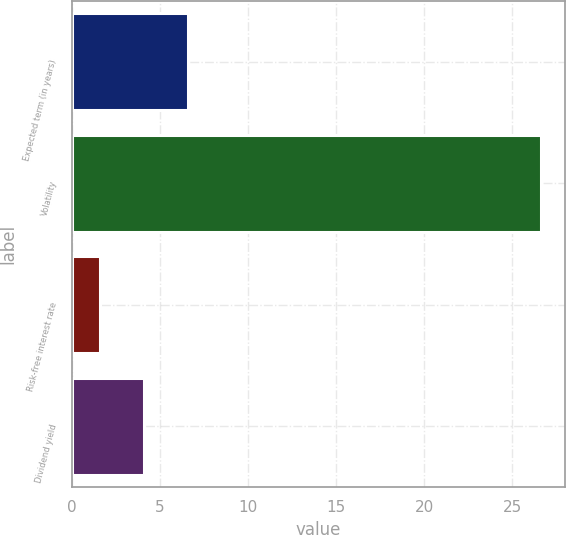Convert chart to OTSL. <chart><loc_0><loc_0><loc_500><loc_500><bar_chart><fcel>Expected term (in years)<fcel>Volatility<fcel>Risk-free interest rate<fcel>Dividend yield<nl><fcel>6.61<fcel>26.65<fcel>1.59<fcel>4.1<nl></chart> 